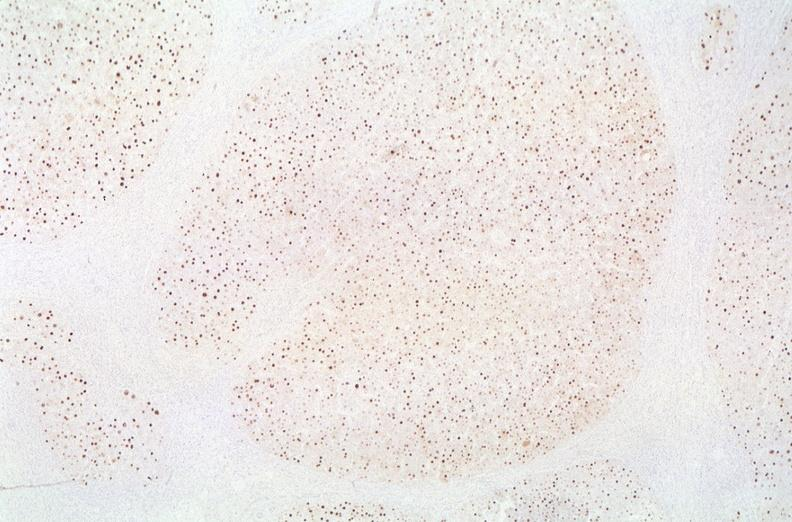does myelomonocytic leukemia show hepatitis b virus, hbve antigen immunohistochemistry?
Answer the question using a single word or phrase. No 